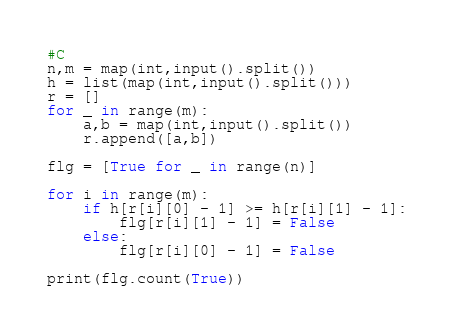Convert code to text. <code><loc_0><loc_0><loc_500><loc_500><_Python_>#C
n,m = map(int,input().split())
h = list(map(int,input().split()))
r = []
for _ in range(m):
    a,b = map(int,input().split())
    r.append([a,b])
    
flg = [True for _ in range(n)]

for i in range(m):
    if h[r[i][0] - 1] >= h[r[i][1] - 1]:
        flg[r[i][1] - 1] = False
    else:
        flg[r[i][0] - 1] = False
        
print(flg.count(True))</code> 